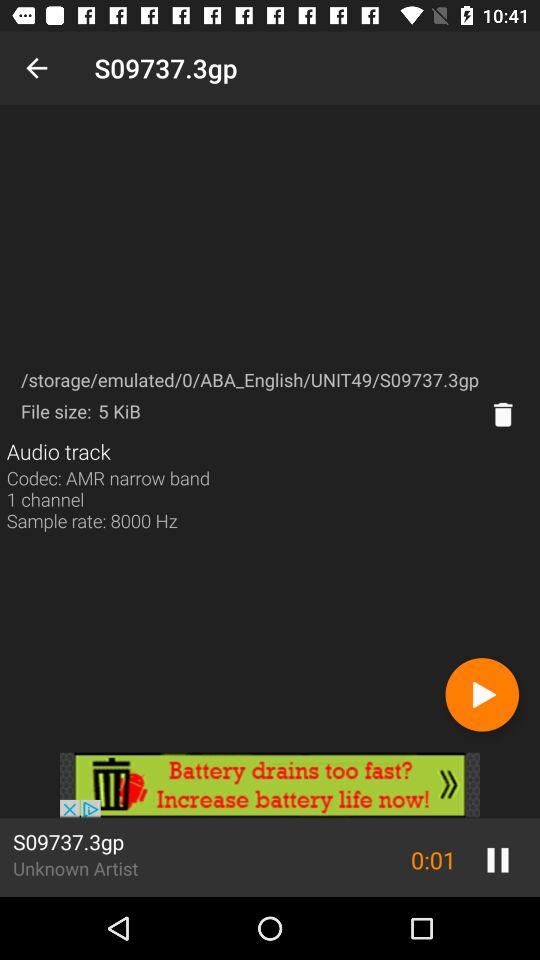What is the sample rate of the track? The sample rate of the track is 8000 Hz. 